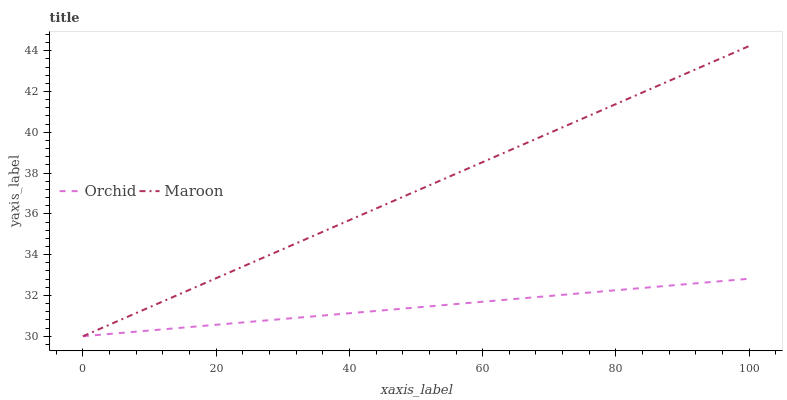Does Orchid have the minimum area under the curve?
Answer yes or no. Yes. Does Maroon have the maximum area under the curve?
Answer yes or no. Yes. Does Orchid have the maximum area under the curve?
Answer yes or no. No. Is Orchid the smoothest?
Answer yes or no. Yes. Is Maroon the roughest?
Answer yes or no. Yes. Is Orchid the roughest?
Answer yes or no. No. Does Maroon have the lowest value?
Answer yes or no. Yes. Does Maroon have the highest value?
Answer yes or no. Yes. Does Orchid have the highest value?
Answer yes or no. No. Does Orchid intersect Maroon?
Answer yes or no. Yes. Is Orchid less than Maroon?
Answer yes or no. No. Is Orchid greater than Maroon?
Answer yes or no. No. 